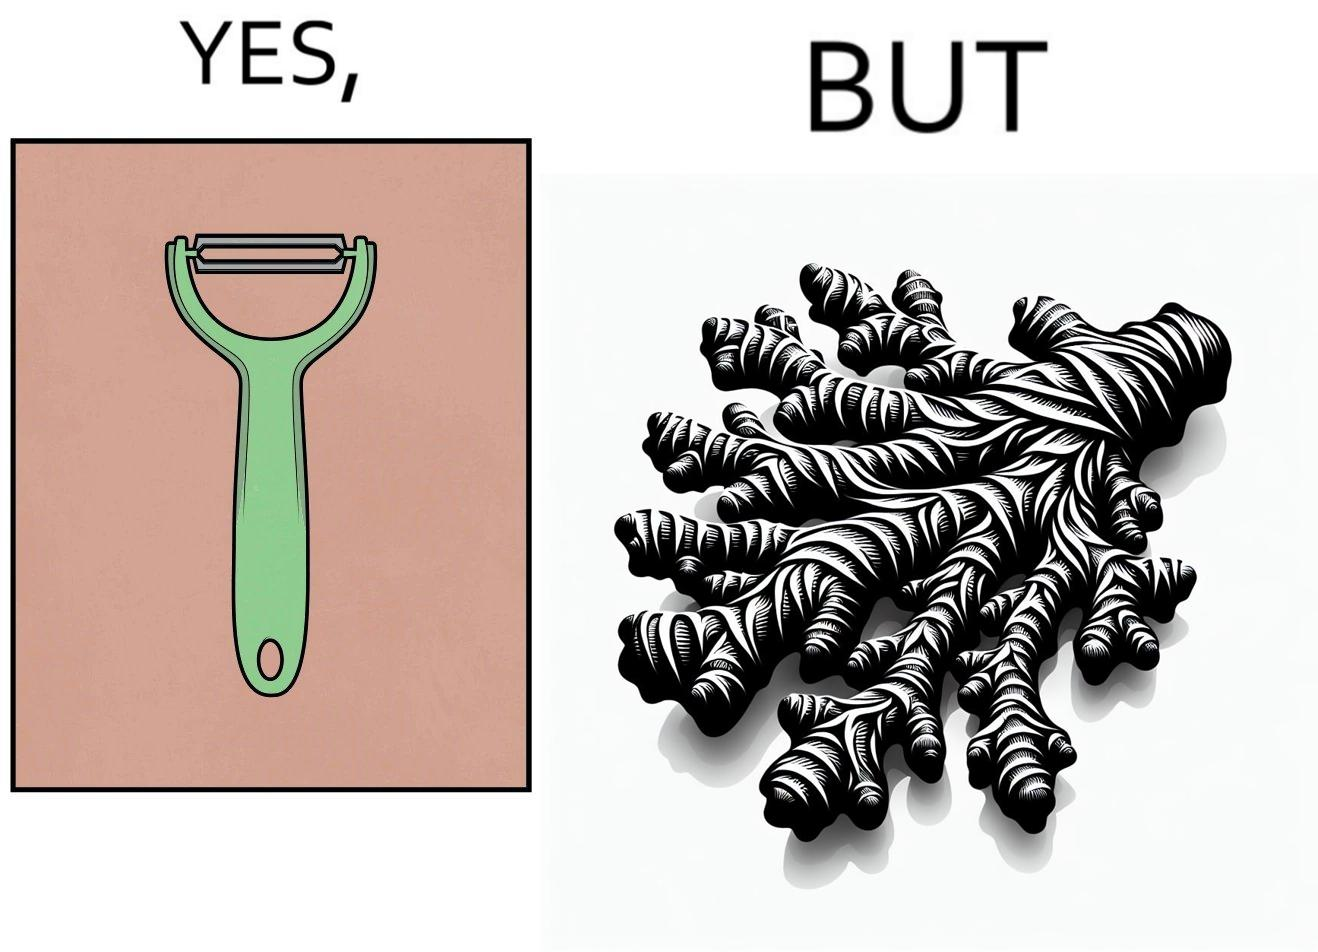What do you see in each half of this image? In the left part of the image: The image shows a green peeler. In the right part of the image: The image shows a ginger root with many branches and a complex shape. 